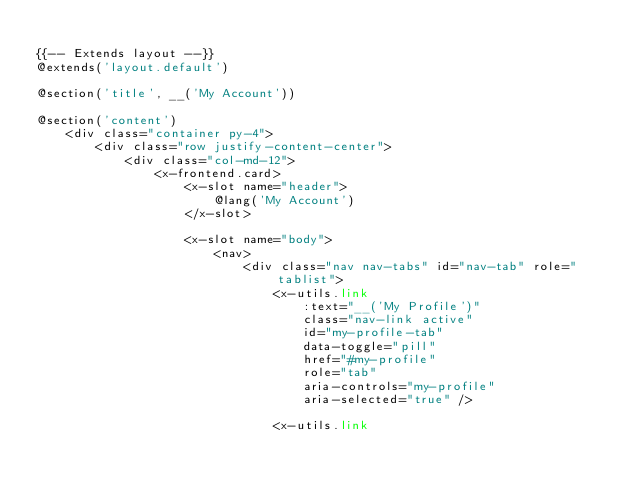<code> <loc_0><loc_0><loc_500><loc_500><_PHP_>
{{-- Extends layout --}}
@extends('layout.default')

@section('title', __('My Account'))

@section('content')
    <div class="container py-4">
        <div class="row justify-content-center">
            <div class="col-md-12">
                <x-frontend.card>
                    <x-slot name="header">
                        @lang('My Account')
                    </x-slot>

                    <x-slot name="body">
                        <nav>
                            <div class="nav nav-tabs" id="nav-tab" role="tablist">
                                <x-utils.link
                                    :text="__('My Profile')"
                                    class="nav-link active"
                                    id="my-profile-tab"
                                    data-toggle="pill"
                                    href="#my-profile"
                                    role="tab"
                                    aria-controls="my-profile"
                                    aria-selected="true" />

                                <x-utils.link</code> 